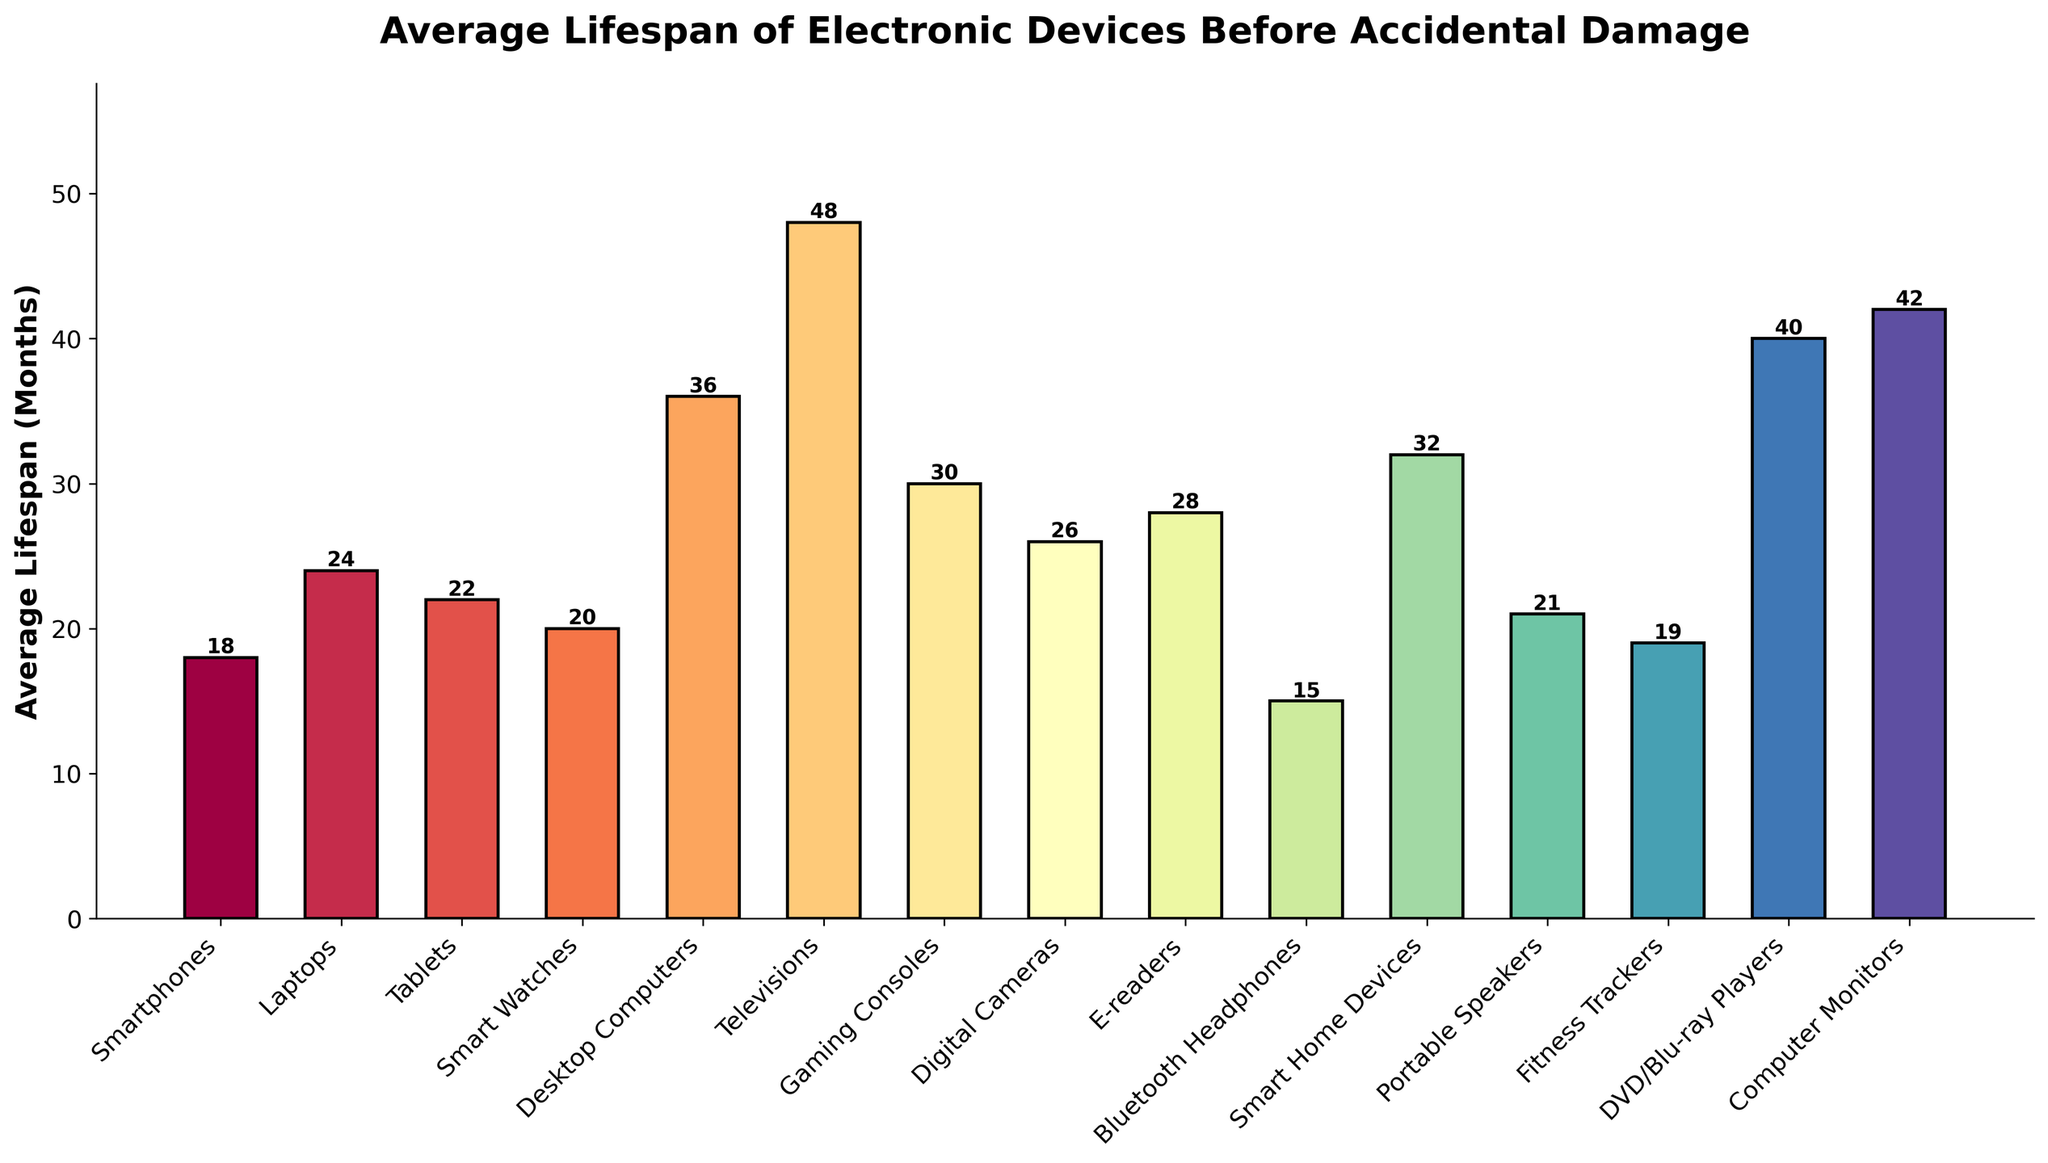Which electronic device has the shortest average lifespan before accidental damage? The electronic device with the shortest bar represents the shortest average lifespan. By looking at the figure, the Bluetooth Headphones have the shortest bar.
Answer: Bluetooth Headphones Which electronic device has the longest average lifespan before accidental damage? The electronic device with the longest bar represents the longest average lifespan. By looking at the figure, Televisions have the longest bar.
Answer: Televisions How much longer is the average lifespan of Televisions compared to Bluetooth Headphones? First, identify the average lifespan of Televisions, which is 48 months, and the average lifespan of Bluetooth Headphones, which is 15 months. Subtract the lifespan of Bluetooth Headphones from Televisions: 48 - 15 = 33 months.
Answer: 33 months What is the average lifespan of Fitness Trackers and Tablets combined? Find the average lifespan of each device: Fitness Trackers (19 months) and Tablets (22 months). Add them together: 19 + 22 = 41 months.
Answer: 41 months Are there more devices with an average lifespan of 30 months or more, or less than 30 months? Count the number of devices with an average lifespan of 30 months or more: Desktop Computers (36), Televisions (48), Gaming Consoles (30), E-readers (28), DVD/Blu-ray Players (40), Computer Monitors (42), Smart Home Devices (32). This totals 7 devices. Count the devices with less than 30 months: Smartphones (18), Laptops (24), Tablets (22), Smart Watches (20), Bluetooth Headphones (15), Portable Speakers (21), Fitness Trackers (19), Digital Cameras (26). This totals 8 devices. There are more devices with a lifespan of less than 30 months.
Answer: Less than 30 months What is the difference in months between the average lifespan of Laptops and Tablets? The average lifespan of Laptops is 24 months, and the average lifespan of Tablets is 22 months. Subtract the lifespan of Tablets from Laptops: 24 - 22 = 2 months.
Answer: 2 months Which category has a higher average lifespan: Gaming Consoles or Smart Watches? Compare the height of the bars for Gaming Consoles and Smart Watches. The bar for Gaming Consoles (30 months) is higher than that for Smart Watches (20 months).
Answer: Gaming Consoles How many months longer do E-readers last compared to Smart Watch? The average lifespan of E-readers is 28 months, and the average lifespan of Smart Watches is 20 months. Subtract the lifespan of Smart Watches from E-readers: 28 - 20 = 8 months.
Answer: 8 months What is the combined average lifespan of the top three categories with the longest lifespan? Identify the three categories with the longest lifespans: Televisions (48 months), Computer Monitors (42 months), DVD/Blu-ray Players (40 months). Add their lifespans: 48 + 42 + 40 = 130 months.
Answer: 130 months 